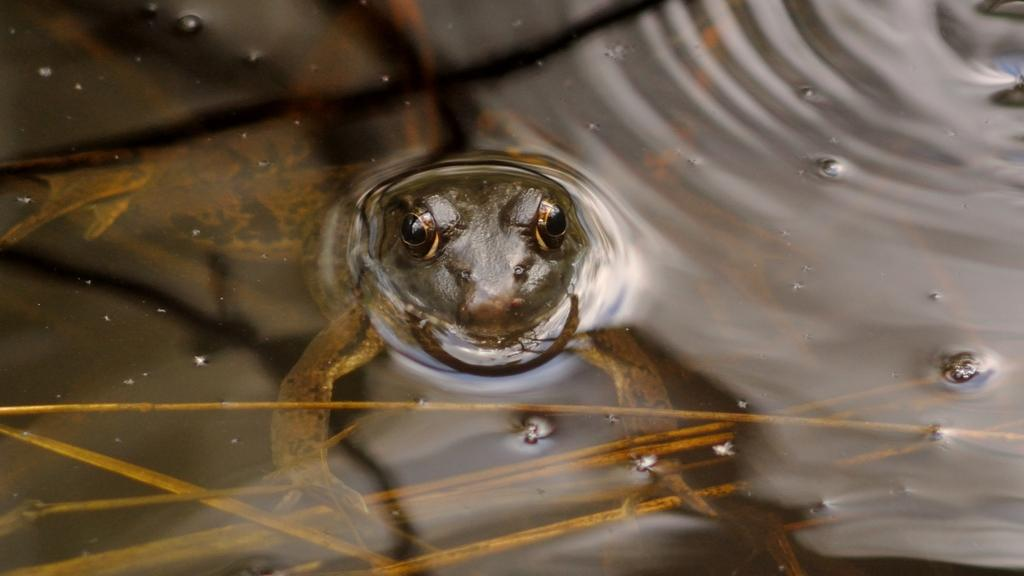What animal is present in the image? There is a frog in the image. Where is the frog located? The frog is in the water. What value does the kettle have in the image? There is no kettle present in the image, so it cannot be assigned a value. 